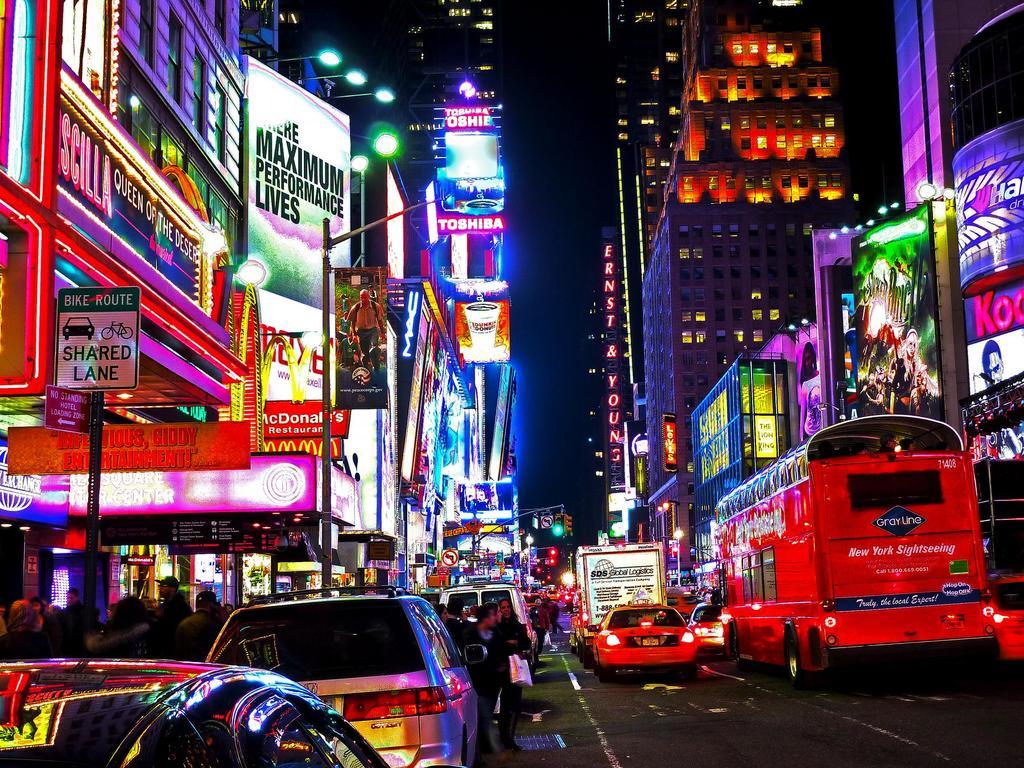Is this place colorful?
Provide a short and direct response. Answering does not require reading text in the image. 